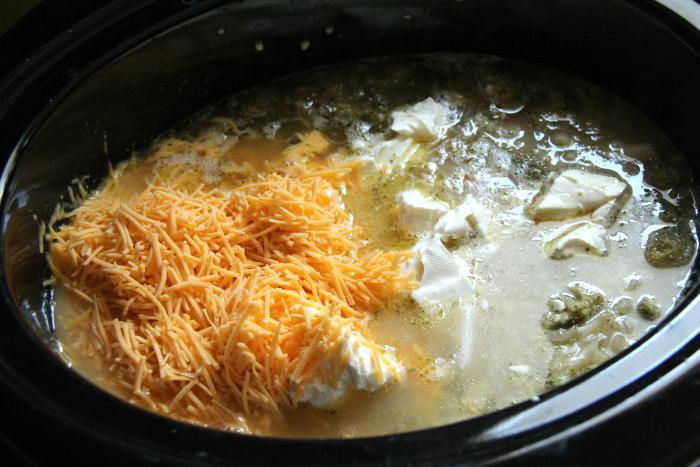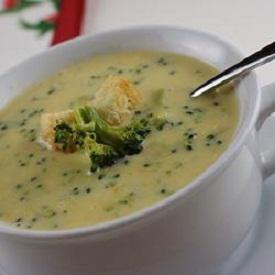The first image is the image on the left, the second image is the image on the right. For the images displayed, is the sentence "At least one bowl of soup is garnished with cheese." factually correct? Answer yes or no. Yes. The first image is the image on the left, the second image is the image on the right. Evaluate the accuracy of this statement regarding the images: "The bwol of the spoon is visible in the image on the left". Is it true? Answer yes or no. No. 